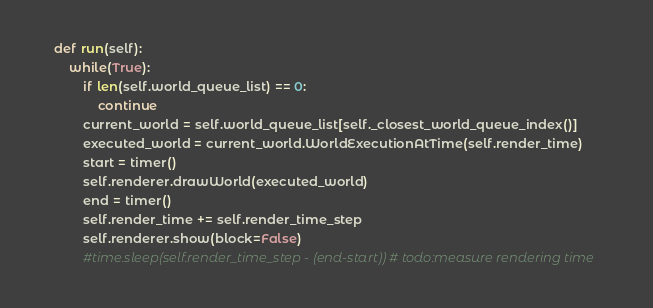Convert code to text. <code><loc_0><loc_0><loc_500><loc_500><_Python_>    def run(self):
        while(True):
            if len(self.world_queue_list) == 0:
                continue
            current_world = self.world_queue_list[self._closest_world_queue_index()]
            executed_world = current_world.WorldExecutionAtTime(self.render_time)
            start = timer()
            self.renderer.drawWorld(executed_world)
            end = timer()
            self.render_time += self.render_time_step
            self.renderer.show(block=False)
            #time.sleep(self.render_time_step - (end-start)) # todo:measure rendering time



</code> 